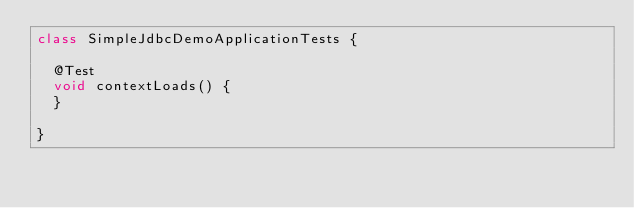Convert code to text. <code><loc_0><loc_0><loc_500><loc_500><_Java_>class SimpleJdbcDemoApplicationTests {

	@Test
	void contextLoads() {
	}

}
</code> 